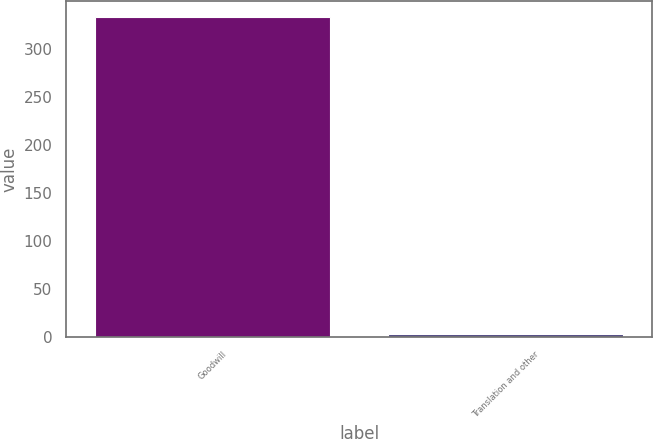Convert chart. <chart><loc_0><loc_0><loc_500><loc_500><bar_chart><fcel>Goodwill<fcel>Translation and other<nl><fcel>333<fcel>3<nl></chart> 